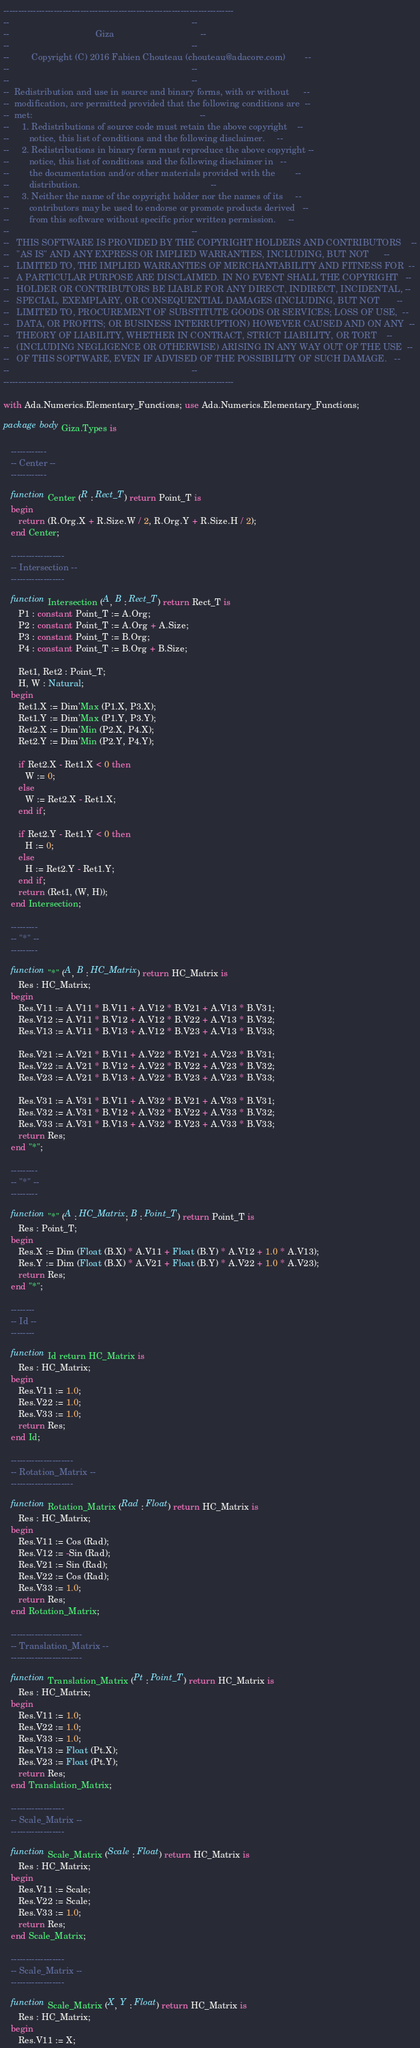<code> <loc_0><loc_0><loc_500><loc_500><_Ada_>------------------------------------------------------------------------------
--                                                                          --
--                                   Giza                                   --
--                                                                          --
--         Copyright (C) 2016 Fabien Chouteau (chouteau@adacore.com)        --
--                                                                          --
--                                                                          --
--  Redistribution and use in source and binary forms, with or without      --
--  modification, are permitted provided that the following conditions are  --
--  met:                                                                    --
--     1. Redistributions of source code must retain the above copyright    --
--        notice, this list of conditions and the following disclaimer.     --
--     2. Redistributions in binary form must reproduce the above copyright --
--        notice, this list of conditions and the following disclaimer in   --
--        the documentation and/or other materials provided with the        --
--        distribution.                                                     --
--     3. Neither the name of the copyright holder nor the names of its     --
--        contributors may be used to endorse or promote products derived   --
--        from this software without specific prior written permission.     --
--                                                                          --
--   THIS SOFTWARE IS PROVIDED BY THE COPYRIGHT HOLDERS AND CONTRIBUTORS    --
--   "AS IS" AND ANY EXPRESS OR IMPLIED WARRANTIES, INCLUDING, BUT NOT      --
--   LIMITED TO, THE IMPLIED WARRANTIES OF MERCHANTABILITY AND FITNESS FOR  --
--   A PARTICULAR PURPOSE ARE DISCLAIMED. IN NO EVENT SHALL THE COPYRIGHT   --
--   HOLDER OR CONTRIBUTORS BE LIABLE FOR ANY DIRECT, INDIRECT, INCIDENTAL, --
--   SPECIAL, EXEMPLARY, OR CONSEQUENTIAL DAMAGES (INCLUDING, BUT NOT       --
--   LIMITED TO, PROCUREMENT OF SUBSTITUTE GOODS OR SERVICES; LOSS OF USE,  --
--   DATA, OR PROFITS; OR BUSINESS INTERRUPTION) HOWEVER CAUSED AND ON ANY  --
--   THEORY OF LIABILITY, WHETHER IN CONTRACT, STRICT LIABILITY, OR TORT    --
--   (INCLUDING NEGLIGENCE OR OTHERWISE) ARISING IN ANY WAY OUT OF THE USE  --
--   OF THIS SOFTWARE, EVEN IF ADVISED OF THE POSSIBILITY OF SUCH DAMAGE.   --
--                                                                          --
------------------------------------------------------------------------------

with Ada.Numerics.Elementary_Functions; use Ada.Numerics.Elementary_Functions;

package body Giza.Types is

   ------------
   -- Center --
   ------------

   function Center (R : Rect_T) return Point_T is
   begin
      return (R.Org.X + R.Size.W / 2, R.Org.Y + R.Size.H / 2);
   end Center;

   ------------------
   -- Intersection --
   ------------------

   function Intersection (A, B : Rect_T) return Rect_T is
      P1 : constant Point_T := A.Org;
      P2 : constant Point_T := A.Org + A.Size;
      P3 : constant Point_T := B.Org;
      P4 : constant Point_T := B.Org + B.Size;

      Ret1, Ret2 : Point_T;
      H, W : Natural;
   begin
      Ret1.X := Dim'Max (P1.X, P3.X);
      Ret1.Y := Dim'Max (P1.Y, P3.Y);
      Ret2.X := Dim'Min (P2.X, P4.X);
      Ret2.Y := Dim'Min (P2.Y, P4.Y);

      if Ret2.X - Ret1.X < 0 then
         W := 0;
      else
         W := Ret2.X - Ret1.X;
      end if;

      if Ret2.Y - Ret1.Y < 0 then
         H := 0;
      else
         H := Ret2.Y - Ret1.Y;
      end if;
      return (Ret1, (W, H));
   end Intersection;

   ---------
   -- "*" --
   ---------

   function "*" (A, B : HC_Matrix) return HC_Matrix is
      Res : HC_Matrix;
   begin
      Res.V11 := A.V11 * B.V11 + A.V12 * B.V21 + A.V13 * B.V31;
      Res.V12 := A.V11 * B.V12 + A.V12 * B.V22 + A.V13 * B.V32;
      Res.V13 := A.V11 * B.V13 + A.V12 * B.V23 + A.V13 * B.V33;

      Res.V21 := A.V21 * B.V11 + A.V22 * B.V21 + A.V23 * B.V31;
      Res.V22 := A.V21 * B.V12 + A.V22 * B.V22 + A.V23 * B.V32;
      Res.V23 := A.V21 * B.V13 + A.V22 * B.V23 + A.V23 * B.V33;

      Res.V31 := A.V31 * B.V11 + A.V32 * B.V21 + A.V33 * B.V31;
      Res.V32 := A.V31 * B.V12 + A.V32 * B.V22 + A.V33 * B.V32;
      Res.V33 := A.V31 * B.V13 + A.V32 * B.V23 + A.V33 * B.V33;
      return Res;
   end "*";

   ---------
   -- "*" --
   ---------

   function "*" (A : HC_Matrix; B : Point_T) return Point_T is
      Res : Point_T;
   begin
      Res.X := Dim (Float (B.X) * A.V11 + Float (B.Y) * A.V12 + 1.0 * A.V13);
      Res.Y := Dim (Float (B.X) * A.V21 + Float (B.Y) * A.V22 + 1.0 * A.V23);
      return Res;
   end "*";

   --------
   -- Id --
   --------

   function Id return HC_Matrix is
      Res : HC_Matrix;
   begin
      Res.V11 := 1.0;
      Res.V22 := 1.0;
      Res.V33 := 1.0;
      return Res;
   end Id;

   ---------------------
   -- Rotation_Matrix --
   ---------------------

   function Rotation_Matrix (Rad : Float) return HC_Matrix is
      Res : HC_Matrix;
   begin
      Res.V11 := Cos (Rad);
      Res.V12 := -Sin (Rad);
      Res.V21 := Sin (Rad);
      Res.V22 := Cos (Rad);
      Res.V33 := 1.0;
      return Res;
   end Rotation_Matrix;

   ------------------------
   -- Translation_Matrix --
   ------------------------

   function Translation_Matrix (Pt : Point_T) return HC_Matrix is
      Res : HC_Matrix;
   begin
      Res.V11 := 1.0;
      Res.V22 := 1.0;
      Res.V33 := 1.0;
      Res.V13 := Float (Pt.X);
      Res.V23 := Float (Pt.Y);
      return Res;
   end Translation_Matrix;

   ------------------
   -- Scale_Matrix --
   ------------------

   function Scale_Matrix (Scale : Float) return HC_Matrix is
      Res : HC_Matrix;
   begin
      Res.V11 := Scale;
      Res.V22 := Scale;
      Res.V33 := 1.0;
      return Res;
   end Scale_Matrix;

   ------------------
   -- Scale_Matrix --
   ------------------

   function Scale_Matrix (X, Y : Float) return HC_Matrix is
      Res : HC_Matrix;
   begin
      Res.V11 := X;</code> 